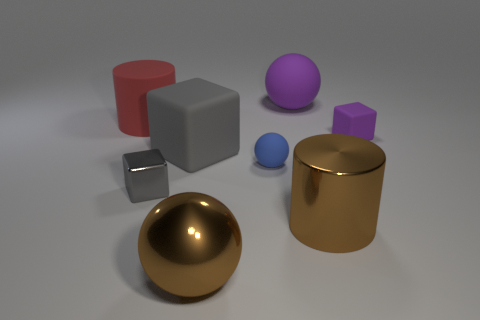Could you describe the lighting of the scene? The scene is evenly lit by what appears to be a diffuse, overhead light source, casting soft shadows beneath the objects and giving a gentle illumination to the entire scene. How does the lighting affect the appearance of the objects? The diffuse lighting accentuates the three-dimensionality of the objects by creating subtle gradients and soft shadows, which provides depth and a sense of spatial arrangement within the composition. 